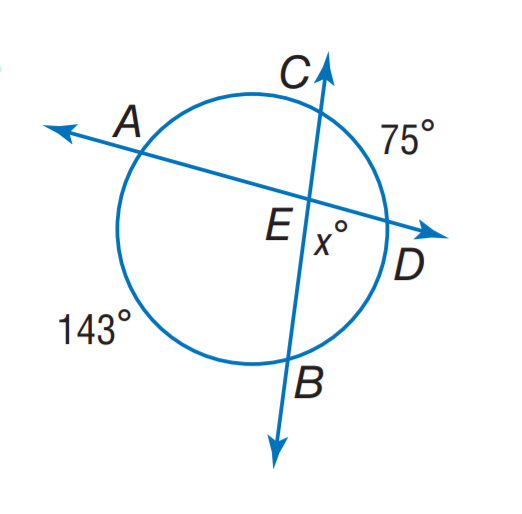Question: Find x.
Choices:
A. 71
B. 75
C. 109
D. 143
Answer with the letter. Answer: A Question: Find m \angle A E B.
Choices:
A. 71
B. 109
C. 142
D. 143
Answer with the letter. Answer: B 